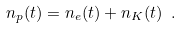<formula> <loc_0><loc_0><loc_500><loc_500>n _ { p } ( t ) = n _ { e } ( t ) + n _ { K } ( t ) \ .</formula> 